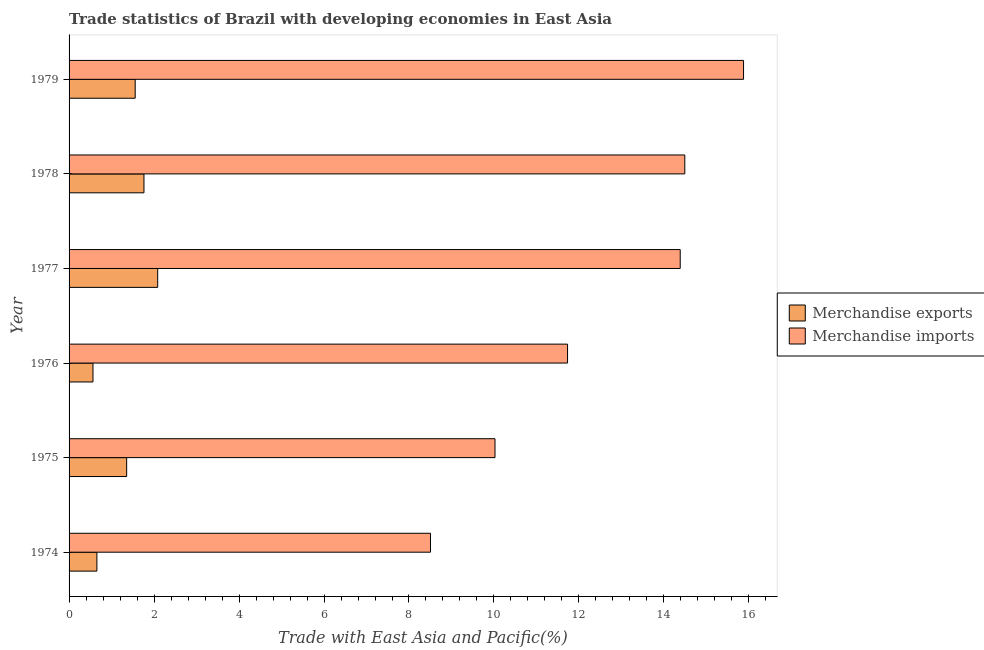How many groups of bars are there?
Offer a terse response. 6. How many bars are there on the 5th tick from the top?
Provide a short and direct response. 2. What is the label of the 3rd group of bars from the top?
Keep it short and to the point. 1977. In how many cases, is the number of bars for a given year not equal to the number of legend labels?
Keep it short and to the point. 0. What is the merchandise exports in 1976?
Your response must be concise. 0.56. Across all years, what is the maximum merchandise imports?
Your answer should be very brief. 15.87. Across all years, what is the minimum merchandise imports?
Make the answer very short. 8.51. In which year was the merchandise imports minimum?
Ensure brevity in your answer.  1974. What is the total merchandise imports in the graph?
Give a very brief answer. 75.01. What is the difference between the merchandise imports in 1974 and that in 1977?
Make the answer very short. -5.88. What is the difference between the merchandise imports in 1974 and the merchandise exports in 1978?
Provide a succinct answer. 6.74. What is the average merchandise exports per year?
Provide a short and direct response. 1.33. In the year 1974, what is the difference between the merchandise imports and merchandise exports?
Your answer should be compact. 7.85. What is the ratio of the merchandise imports in 1975 to that in 1978?
Offer a very short reply. 0.69. Is the merchandise exports in 1976 less than that in 1979?
Your response must be concise. Yes. Is the difference between the merchandise exports in 1975 and 1976 greater than the difference between the merchandise imports in 1975 and 1976?
Give a very brief answer. Yes. What is the difference between the highest and the second highest merchandise imports?
Your response must be concise. 1.38. What is the difference between the highest and the lowest merchandise imports?
Make the answer very short. 7.37. In how many years, is the merchandise imports greater than the average merchandise imports taken over all years?
Offer a terse response. 3. Is the sum of the merchandise exports in 1978 and 1979 greater than the maximum merchandise imports across all years?
Your answer should be very brief. No. What does the 2nd bar from the bottom in 1974 represents?
Ensure brevity in your answer.  Merchandise imports. How many bars are there?
Offer a terse response. 12. Are all the bars in the graph horizontal?
Offer a very short reply. Yes. What is the difference between two consecutive major ticks on the X-axis?
Offer a terse response. 2. Does the graph contain any zero values?
Make the answer very short. No. Does the graph contain grids?
Your answer should be compact. No. How many legend labels are there?
Give a very brief answer. 2. How are the legend labels stacked?
Your response must be concise. Vertical. What is the title of the graph?
Ensure brevity in your answer.  Trade statistics of Brazil with developing economies in East Asia. What is the label or title of the X-axis?
Your answer should be very brief. Trade with East Asia and Pacific(%). What is the Trade with East Asia and Pacific(%) of Merchandise exports in 1974?
Your answer should be very brief. 0.65. What is the Trade with East Asia and Pacific(%) in Merchandise imports in 1974?
Keep it short and to the point. 8.51. What is the Trade with East Asia and Pacific(%) in Merchandise exports in 1975?
Provide a succinct answer. 1.36. What is the Trade with East Asia and Pacific(%) of Merchandise imports in 1975?
Offer a terse response. 10.02. What is the Trade with East Asia and Pacific(%) of Merchandise exports in 1976?
Provide a succinct answer. 0.56. What is the Trade with East Asia and Pacific(%) in Merchandise imports in 1976?
Your response must be concise. 11.73. What is the Trade with East Asia and Pacific(%) of Merchandise exports in 1977?
Offer a terse response. 2.09. What is the Trade with East Asia and Pacific(%) in Merchandise imports in 1977?
Offer a terse response. 14.38. What is the Trade with East Asia and Pacific(%) in Merchandise exports in 1978?
Provide a short and direct response. 1.76. What is the Trade with East Asia and Pacific(%) of Merchandise imports in 1978?
Ensure brevity in your answer.  14.49. What is the Trade with East Asia and Pacific(%) of Merchandise exports in 1979?
Your response must be concise. 1.56. What is the Trade with East Asia and Pacific(%) in Merchandise imports in 1979?
Provide a short and direct response. 15.87. Across all years, what is the maximum Trade with East Asia and Pacific(%) in Merchandise exports?
Offer a terse response. 2.09. Across all years, what is the maximum Trade with East Asia and Pacific(%) of Merchandise imports?
Offer a very short reply. 15.87. Across all years, what is the minimum Trade with East Asia and Pacific(%) in Merchandise exports?
Your answer should be compact. 0.56. Across all years, what is the minimum Trade with East Asia and Pacific(%) in Merchandise imports?
Your answer should be very brief. 8.51. What is the total Trade with East Asia and Pacific(%) of Merchandise exports in the graph?
Offer a terse response. 7.98. What is the total Trade with East Asia and Pacific(%) of Merchandise imports in the graph?
Ensure brevity in your answer.  75.01. What is the difference between the Trade with East Asia and Pacific(%) of Merchandise exports in 1974 and that in 1975?
Provide a short and direct response. -0.7. What is the difference between the Trade with East Asia and Pacific(%) of Merchandise imports in 1974 and that in 1975?
Keep it short and to the point. -1.52. What is the difference between the Trade with East Asia and Pacific(%) in Merchandise exports in 1974 and that in 1976?
Offer a terse response. 0.09. What is the difference between the Trade with East Asia and Pacific(%) in Merchandise imports in 1974 and that in 1976?
Offer a terse response. -3.23. What is the difference between the Trade with East Asia and Pacific(%) in Merchandise exports in 1974 and that in 1977?
Make the answer very short. -1.43. What is the difference between the Trade with East Asia and Pacific(%) in Merchandise imports in 1974 and that in 1977?
Give a very brief answer. -5.88. What is the difference between the Trade with East Asia and Pacific(%) in Merchandise exports in 1974 and that in 1978?
Provide a succinct answer. -1.11. What is the difference between the Trade with East Asia and Pacific(%) of Merchandise imports in 1974 and that in 1978?
Provide a short and direct response. -5.99. What is the difference between the Trade with East Asia and Pacific(%) in Merchandise exports in 1974 and that in 1979?
Make the answer very short. -0.9. What is the difference between the Trade with East Asia and Pacific(%) of Merchandise imports in 1974 and that in 1979?
Make the answer very short. -7.37. What is the difference between the Trade with East Asia and Pacific(%) of Merchandise exports in 1975 and that in 1976?
Offer a terse response. 0.79. What is the difference between the Trade with East Asia and Pacific(%) in Merchandise imports in 1975 and that in 1976?
Your answer should be compact. -1.71. What is the difference between the Trade with East Asia and Pacific(%) in Merchandise exports in 1975 and that in 1977?
Provide a succinct answer. -0.73. What is the difference between the Trade with East Asia and Pacific(%) of Merchandise imports in 1975 and that in 1977?
Your answer should be compact. -4.36. What is the difference between the Trade with East Asia and Pacific(%) of Merchandise exports in 1975 and that in 1978?
Provide a short and direct response. -0.41. What is the difference between the Trade with East Asia and Pacific(%) of Merchandise imports in 1975 and that in 1978?
Give a very brief answer. -4.47. What is the difference between the Trade with East Asia and Pacific(%) of Merchandise exports in 1975 and that in 1979?
Your response must be concise. -0.2. What is the difference between the Trade with East Asia and Pacific(%) in Merchandise imports in 1975 and that in 1979?
Your response must be concise. -5.85. What is the difference between the Trade with East Asia and Pacific(%) of Merchandise exports in 1976 and that in 1977?
Keep it short and to the point. -1.52. What is the difference between the Trade with East Asia and Pacific(%) in Merchandise imports in 1976 and that in 1977?
Keep it short and to the point. -2.65. What is the difference between the Trade with East Asia and Pacific(%) of Merchandise exports in 1976 and that in 1978?
Your response must be concise. -1.2. What is the difference between the Trade with East Asia and Pacific(%) in Merchandise imports in 1976 and that in 1978?
Provide a short and direct response. -2.76. What is the difference between the Trade with East Asia and Pacific(%) in Merchandise exports in 1976 and that in 1979?
Your answer should be very brief. -0.99. What is the difference between the Trade with East Asia and Pacific(%) in Merchandise imports in 1976 and that in 1979?
Your answer should be compact. -4.14. What is the difference between the Trade with East Asia and Pacific(%) in Merchandise exports in 1977 and that in 1978?
Make the answer very short. 0.32. What is the difference between the Trade with East Asia and Pacific(%) of Merchandise imports in 1977 and that in 1978?
Ensure brevity in your answer.  -0.11. What is the difference between the Trade with East Asia and Pacific(%) in Merchandise exports in 1977 and that in 1979?
Ensure brevity in your answer.  0.53. What is the difference between the Trade with East Asia and Pacific(%) in Merchandise imports in 1977 and that in 1979?
Your answer should be compact. -1.49. What is the difference between the Trade with East Asia and Pacific(%) of Merchandise exports in 1978 and that in 1979?
Your answer should be very brief. 0.21. What is the difference between the Trade with East Asia and Pacific(%) of Merchandise imports in 1978 and that in 1979?
Provide a short and direct response. -1.38. What is the difference between the Trade with East Asia and Pacific(%) in Merchandise exports in 1974 and the Trade with East Asia and Pacific(%) in Merchandise imports in 1975?
Provide a succinct answer. -9.37. What is the difference between the Trade with East Asia and Pacific(%) of Merchandise exports in 1974 and the Trade with East Asia and Pacific(%) of Merchandise imports in 1976?
Your answer should be very brief. -11.08. What is the difference between the Trade with East Asia and Pacific(%) of Merchandise exports in 1974 and the Trade with East Asia and Pacific(%) of Merchandise imports in 1977?
Keep it short and to the point. -13.73. What is the difference between the Trade with East Asia and Pacific(%) in Merchandise exports in 1974 and the Trade with East Asia and Pacific(%) in Merchandise imports in 1978?
Keep it short and to the point. -13.84. What is the difference between the Trade with East Asia and Pacific(%) in Merchandise exports in 1974 and the Trade with East Asia and Pacific(%) in Merchandise imports in 1979?
Your answer should be very brief. -15.22. What is the difference between the Trade with East Asia and Pacific(%) of Merchandise exports in 1975 and the Trade with East Asia and Pacific(%) of Merchandise imports in 1976?
Ensure brevity in your answer.  -10.38. What is the difference between the Trade with East Asia and Pacific(%) in Merchandise exports in 1975 and the Trade with East Asia and Pacific(%) in Merchandise imports in 1977?
Make the answer very short. -13.03. What is the difference between the Trade with East Asia and Pacific(%) in Merchandise exports in 1975 and the Trade with East Asia and Pacific(%) in Merchandise imports in 1978?
Your response must be concise. -13.14. What is the difference between the Trade with East Asia and Pacific(%) in Merchandise exports in 1975 and the Trade with East Asia and Pacific(%) in Merchandise imports in 1979?
Make the answer very short. -14.52. What is the difference between the Trade with East Asia and Pacific(%) of Merchandise exports in 1976 and the Trade with East Asia and Pacific(%) of Merchandise imports in 1977?
Offer a very short reply. -13.82. What is the difference between the Trade with East Asia and Pacific(%) in Merchandise exports in 1976 and the Trade with East Asia and Pacific(%) in Merchandise imports in 1978?
Offer a very short reply. -13.93. What is the difference between the Trade with East Asia and Pacific(%) of Merchandise exports in 1976 and the Trade with East Asia and Pacific(%) of Merchandise imports in 1979?
Keep it short and to the point. -15.31. What is the difference between the Trade with East Asia and Pacific(%) in Merchandise exports in 1977 and the Trade with East Asia and Pacific(%) in Merchandise imports in 1978?
Provide a short and direct response. -12.41. What is the difference between the Trade with East Asia and Pacific(%) in Merchandise exports in 1977 and the Trade with East Asia and Pacific(%) in Merchandise imports in 1979?
Provide a succinct answer. -13.79. What is the difference between the Trade with East Asia and Pacific(%) of Merchandise exports in 1978 and the Trade with East Asia and Pacific(%) of Merchandise imports in 1979?
Your answer should be compact. -14.11. What is the average Trade with East Asia and Pacific(%) in Merchandise exports per year?
Offer a very short reply. 1.33. What is the average Trade with East Asia and Pacific(%) in Merchandise imports per year?
Give a very brief answer. 12.5. In the year 1974, what is the difference between the Trade with East Asia and Pacific(%) of Merchandise exports and Trade with East Asia and Pacific(%) of Merchandise imports?
Offer a terse response. -7.85. In the year 1975, what is the difference between the Trade with East Asia and Pacific(%) of Merchandise exports and Trade with East Asia and Pacific(%) of Merchandise imports?
Keep it short and to the point. -8.67. In the year 1976, what is the difference between the Trade with East Asia and Pacific(%) of Merchandise exports and Trade with East Asia and Pacific(%) of Merchandise imports?
Provide a short and direct response. -11.17. In the year 1977, what is the difference between the Trade with East Asia and Pacific(%) in Merchandise exports and Trade with East Asia and Pacific(%) in Merchandise imports?
Your answer should be compact. -12.3. In the year 1978, what is the difference between the Trade with East Asia and Pacific(%) of Merchandise exports and Trade with East Asia and Pacific(%) of Merchandise imports?
Provide a succinct answer. -12.73. In the year 1979, what is the difference between the Trade with East Asia and Pacific(%) of Merchandise exports and Trade with East Asia and Pacific(%) of Merchandise imports?
Keep it short and to the point. -14.32. What is the ratio of the Trade with East Asia and Pacific(%) of Merchandise exports in 1974 to that in 1975?
Your answer should be very brief. 0.48. What is the ratio of the Trade with East Asia and Pacific(%) in Merchandise imports in 1974 to that in 1975?
Give a very brief answer. 0.85. What is the ratio of the Trade with East Asia and Pacific(%) in Merchandise exports in 1974 to that in 1976?
Provide a short and direct response. 1.16. What is the ratio of the Trade with East Asia and Pacific(%) in Merchandise imports in 1974 to that in 1976?
Offer a terse response. 0.72. What is the ratio of the Trade with East Asia and Pacific(%) in Merchandise exports in 1974 to that in 1977?
Your answer should be compact. 0.31. What is the ratio of the Trade with East Asia and Pacific(%) in Merchandise imports in 1974 to that in 1977?
Give a very brief answer. 0.59. What is the ratio of the Trade with East Asia and Pacific(%) of Merchandise exports in 1974 to that in 1978?
Your response must be concise. 0.37. What is the ratio of the Trade with East Asia and Pacific(%) of Merchandise imports in 1974 to that in 1978?
Your response must be concise. 0.59. What is the ratio of the Trade with East Asia and Pacific(%) of Merchandise exports in 1974 to that in 1979?
Your answer should be very brief. 0.42. What is the ratio of the Trade with East Asia and Pacific(%) in Merchandise imports in 1974 to that in 1979?
Give a very brief answer. 0.54. What is the ratio of the Trade with East Asia and Pacific(%) in Merchandise exports in 1975 to that in 1976?
Your answer should be compact. 2.41. What is the ratio of the Trade with East Asia and Pacific(%) of Merchandise imports in 1975 to that in 1976?
Your answer should be compact. 0.85. What is the ratio of the Trade with East Asia and Pacific(%) of Merchandise exports in 1975 to that in 1977?
Ensure brevity in your answer.  0.65. What is the ratio of the Trade with East Asia and Pacific(%) of Merchandise imports in 1975 to that in 1977?
Your answer should be compact. 0.7. What is the ratio of the Trade with East Asia and Pacific(%) of Merchandise exports in 1975 to that in 1978?
Provide a succinct answer. 0.77. What is the ratio of the Trade with East Asia and Pacific(%) in Merchandise imports in 1975 to that in 1978?
Provide a short and direct response. 0.69. What is the ratio of the Trade with East Asia and Pacific(%) in Merchandise exports in 1975 to that in 1979?
Provide a succinct answer. 0.87. What is the ratio of the Trade with East Asia and Pacific(%) of Merchandise imports in 1975 to that in 1979?
Your response must be concise. 0.63. What is the ratio of the Trade with East Asia and Pacific(%) in Merchandise exports in 1976 to that in 1977?
Ensure brevity in your answer.  0.27. What is the ratio of the Trade with East Asia and Pacific(%) in Merchandise imports in 1976 to that in 1977?
Keep it short and to the point. 0.82. What is the ratio of the Trade with East Asia and Pacific(%) in Merchandise exports in 1976 to that in 1978?
Provide a succinct answer. 0.32. What is the ratio of the Trade with East Asia and Pacific(%) of Merchandise imports in 1976 to that in 1978?
Your response must be concise. 0.81. What is the ratio of the Trade with East Asia and Pacific(%) in Merchandise exports in 1976 to that in 1979?
Your answer should be very brief. 0.36. What is the ratio of the Trade with East Asia and Pacific(%) in Merchandise imports in 1976 to that in 1979?
Offer a terse response. 0.74. What is the ratio of the Trade with East Asia and Pacific(%) of Merchandise exports in 1977 to that in 1978?
Provide a short and direct response. 1.18. What is the ratio of the Trade with East Asia and Pacific(%) in Merchandise exports in 1977 to that in 1979?
Provide a succinct answer. 1.34. What is the ratio of the Trade with East Asia and Pacific(%) of Merchandise imports in 1977 to that in 1979?
Provide a succinct answer. 0.91. What is the ratio of the Trade with East Asia and Pacific(%) of Merchandise exports in 1978 to that in 1979?
Your answer should be very brief. 1.13. What is the ratio of the Trade with East Asia and Pacific(%) of Merchandise imports in 1978 to that in 1979?
Provide a succinct answer. 0.91. What is the difference between the highest and the second highest Trade with East Asia and Pacific(%) of Merchandise exports?
Ensure brevity in your answer.  0.32. What is the difference between the highest and the second highest Trade with East Asia and Pacific(%) in Merchandise imports?
Ensure brevity in your answer.  1.38. What is the difference between the highest and the lowest Trade with East Asia and Pacific(%) in Merchandise exports?
Keep it short and to the point. 1.52. What is the difference between the highest and the lowest Trade with East Asia and Pacific(%) in Merchandise imports?
Your answer should be very brief. 7.37. 